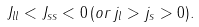Convert formula to latex. <formula><loc_0><loc_0><loc_500><loc_500>J _ { l l } < J _ { s s } < 0 \, ( o r \, j _ { l } > j _ { s } > 0 ) .</formula> 